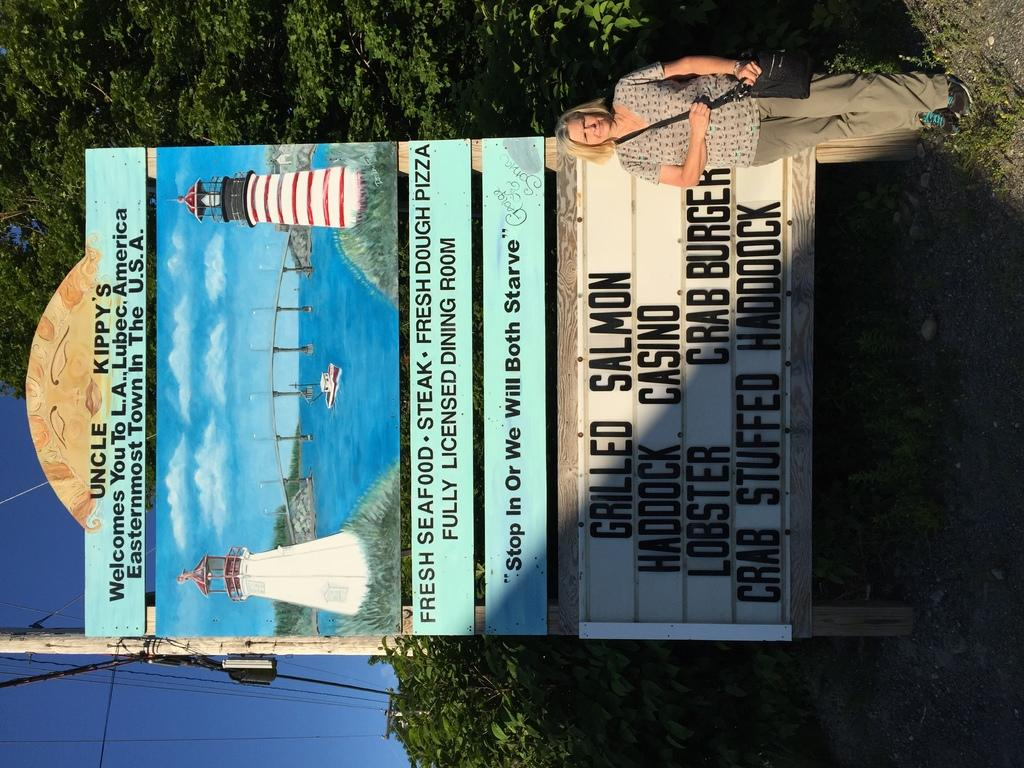<image>
Write a terse but informative summary of the picture. A restaurant sign stating that one of its specials is grilled salmon. 